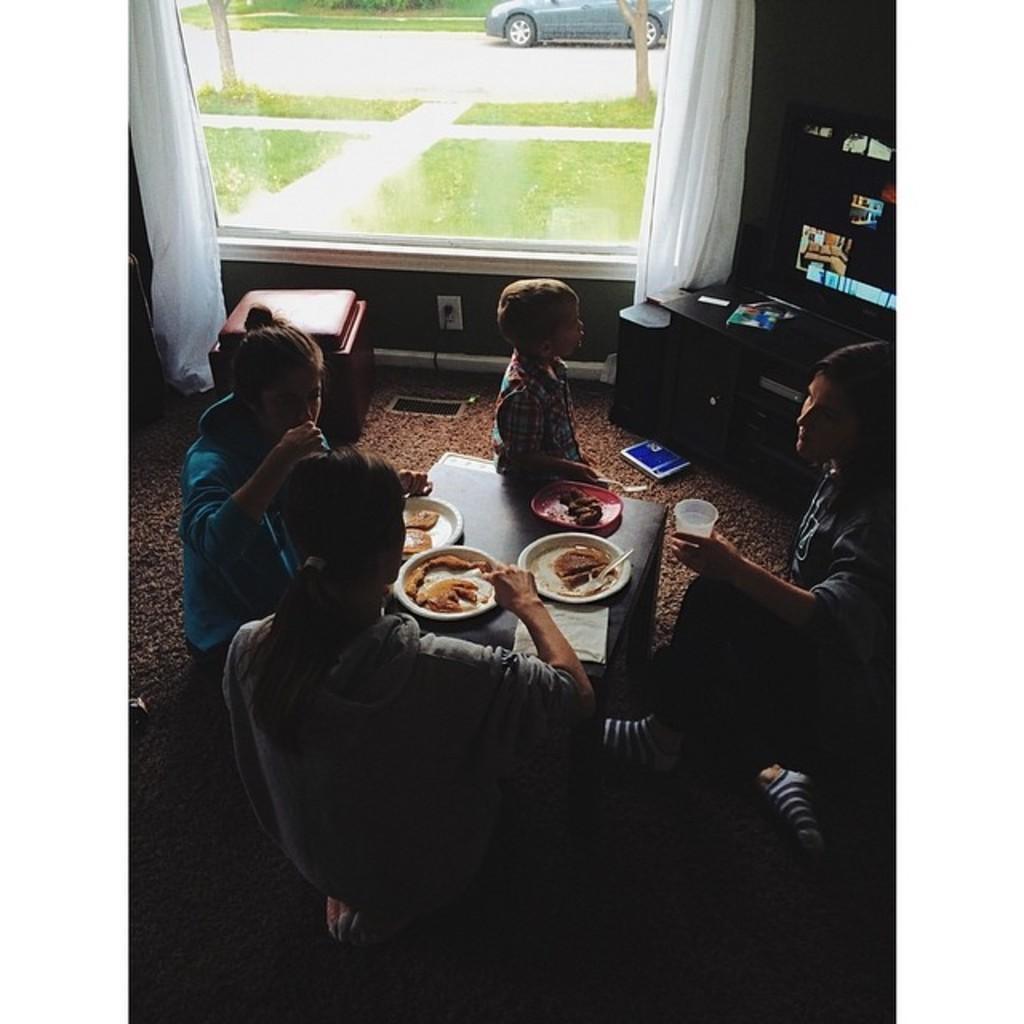Could you give a brief overview of what you see in this image? The picture is taken inside a room. There are few people having food. In the middle there is table on the table there are foods on plates. In the top right there is a table on that there is a television. In the ground there is a carpet. In the background there is a window through which we can see outside. There are two curtains beside the window. Outside there is a car. 